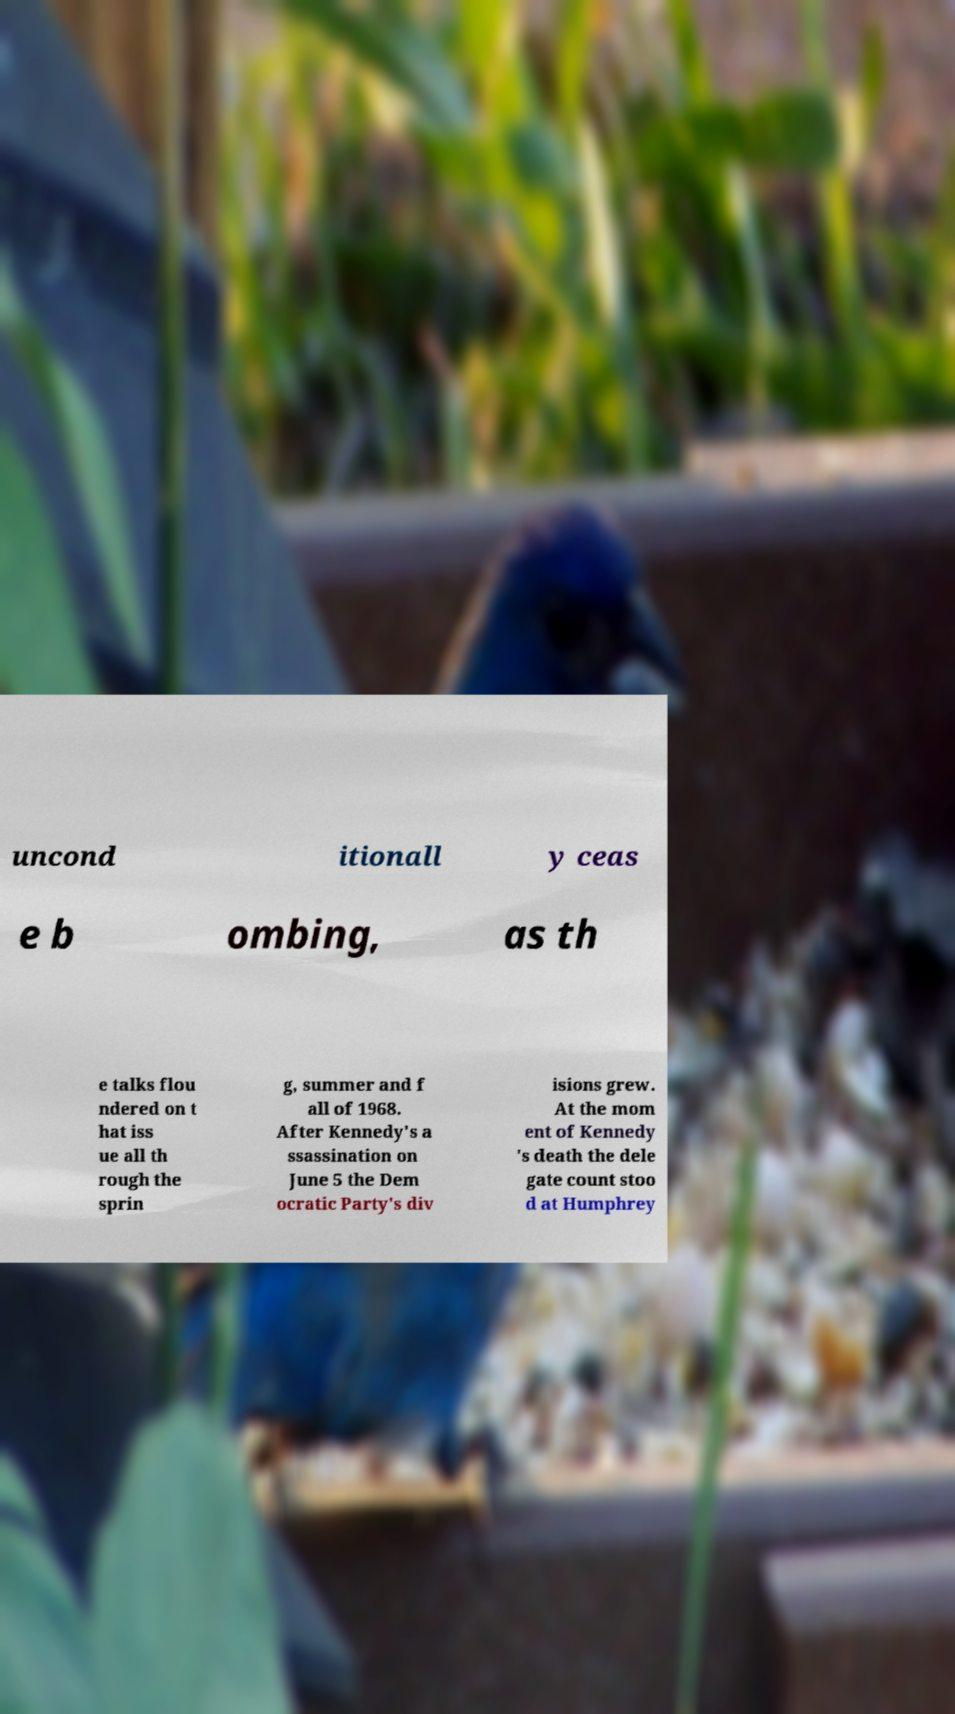Can you read and provide the text displayed in the image?This photo seems to have some interesting text. Can you extract and type it out for me? uncond itionall y ceas e b ombing, as th e talks flou ndered on t hat iss ue all th rough the sprin g, summer and f all of 1968. After Kennedy's a ssassination on June 5 the Dem ocratic Party's div isions grew. At the mom ent of Kennedy 's death the dele gate count stoo d at Humphrey 